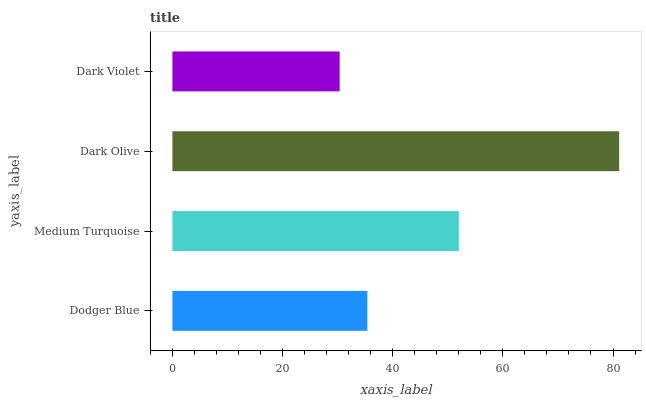Is Dark Violet the minimum?
Answer yes or no. Yes. Is Dark Olive the maximum?
Answer yes or no. Yes. Is Medium Turquoise the minimum?
Answer yes or no. No. Is Medium Turquoise the maximum?
Answer yes or no. No. Is Medium Turquoise greater than Dodger Blue?
Answer yes or no. Yes. Is Dodger Blue less than Medium Turquoise?
Answer yes or no. Yes. Is Dodger Blue greater than Medium Turquoise?
Answer yes or no. No. Is Medium Turquoise less than Dodger Blue?
Answer yes or no. No. Is Medium Turquoise the high median?
Answer yes or no. Yes. Is Dodger Blue the low median?
Answer yes or no. Yes. Is Dark Olive the high median?
Answer yes or no. No. Is Medium Turquoise the low median?
Answer yes or no. No. 